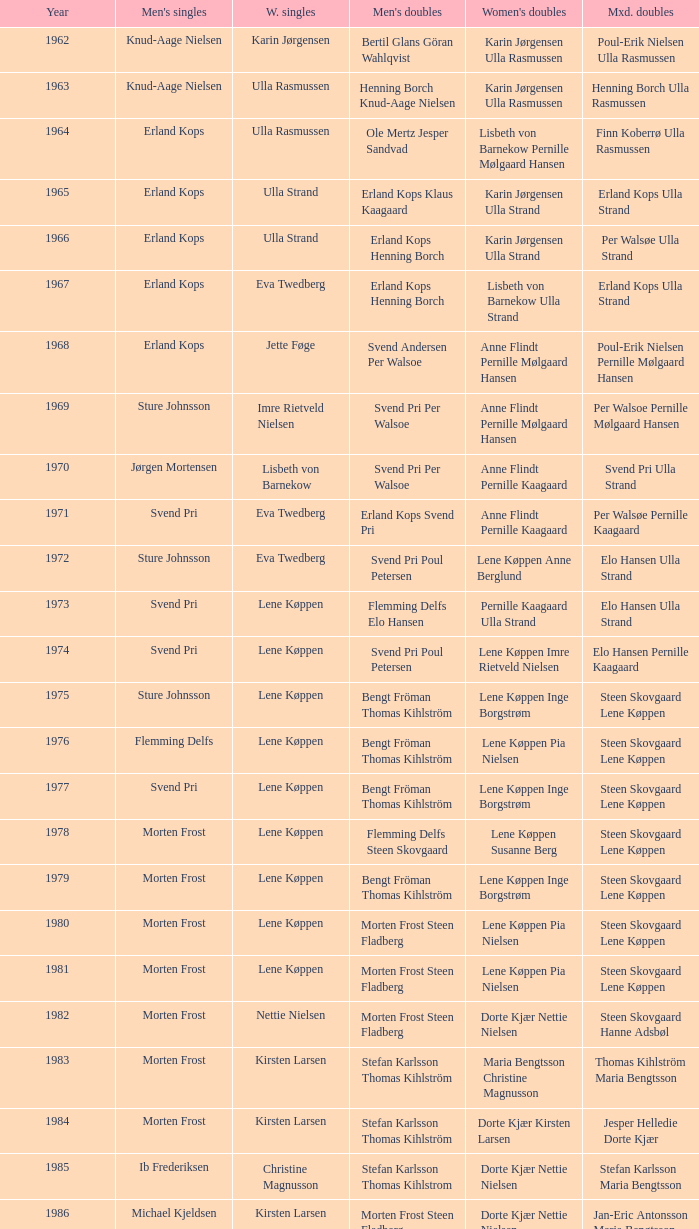Who won the men's doubles the year Pernille Nedergaard won the women's singles? Thomas Stuer-Lauridsen Max Gandrup. 